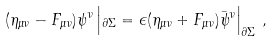<formula> <loc_0><loc_0><loc_500><loc_500>( \eta _ { \mu \nu } - F _ { \mu \nu } ) \psi ^ { \nu } \left | _ { \partial \Sigma } = \epsilon ( \eta _ { \mu \nu } + F _ { \mu \nu } ) { \bar { \psi } } ^ { \nu } \right | _ { \partial \Sigma } \, ,</formula> 